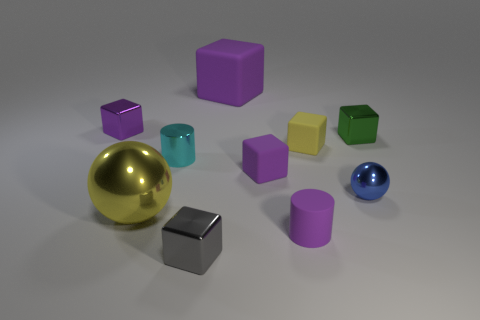Subtract all gray cylinders. How many purple blocks are left? 3 Subtract 2 cubes. How many cubes are left? 4 Subtract all green cubes. How many cubes are left? 5 Subtract all green metal cubes. How many cubes are left? 5 Subtract all blue cubes. Subtract all gray cylinders. How many cubes are left? 6 Subtract all cylinders. How many objects are left? 8 Add 2 blue objects. How many blue objects exist? 3 Subtract 0 green spheres. How many objects are left? 10 Subtract all small gray metallic things. Subtract all small metal balls. How many objects are left? 8 Add 8 large yellow metal spheres. How many large yellow metal spheres are left? 9 